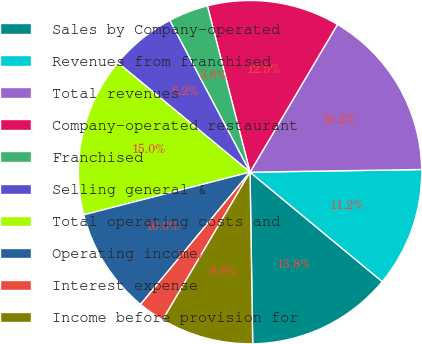Convert chart to OTSL. <chart><loc_0><loc_0><loc_500><loc_500><pie_chart><fcel>Sales by Company-operated<fcel>Revenues from franchised<fcel>Total revenues<fcel>Company-operated restaurant<fcel>Franchised<fcel>Selling general &<fcel>Total operating costs and<fcel>Operating income<fcel>Interest expense<fcel>Income before provision for<nl><fcel>13.75%<fcel>11.25%<fcel>16.25%<fcel>12.5%<fcel>3.75%<fcel>6.25%<fcel>15.0%<fcel>10.0%<fcel>2.5%<fcel>8.75%<nl></chart> 